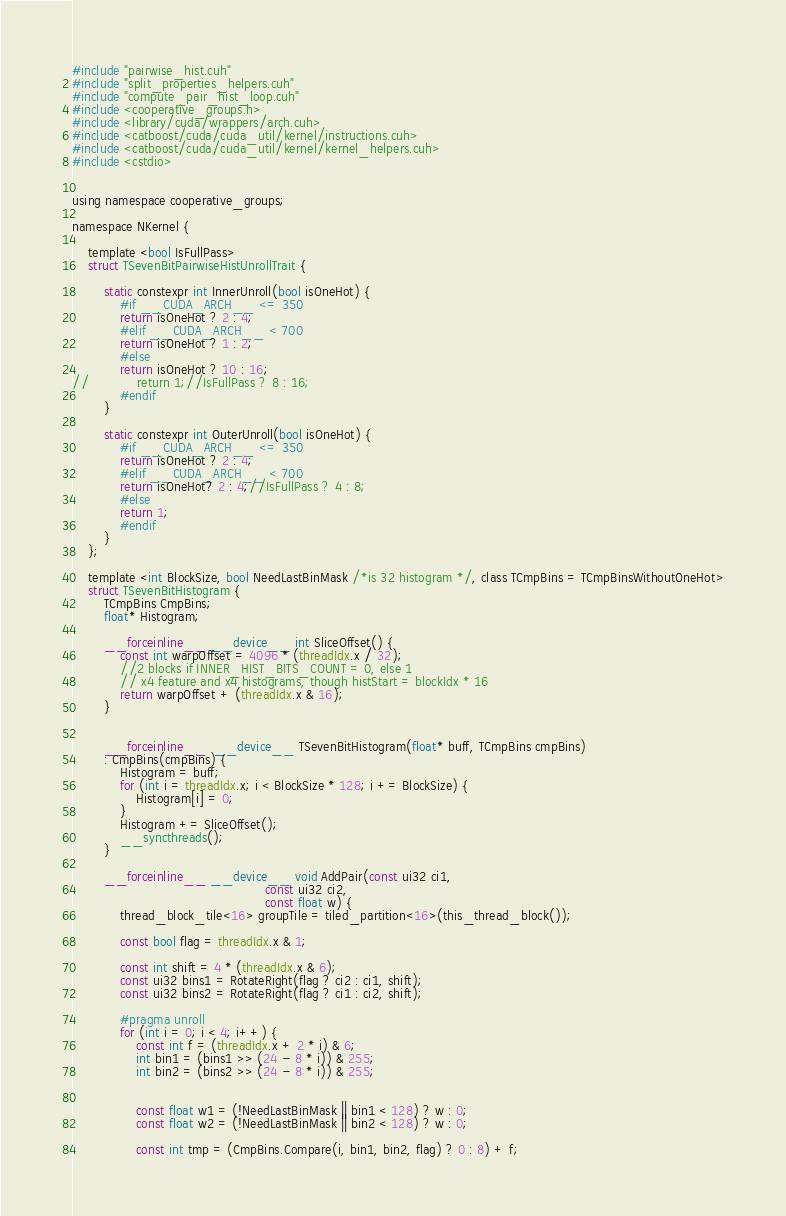Convert code to text. <code><loc_0><loc_0><loc_500><loc_500><_Cuda_>#include "pairwise_hist.cuh"
#include "split_properties_helpers.cuh"
#include "compute_pair_hist_loop.cuh"
#include <cooperative_groups.h>
#include <library/cuda/wrappers/arch.cuh>
#include <catboost/cuda/cuda_util/kernel/instructions.cuh>
#include <catboost/cuda/cuda_util/kernel/kernel_helpers.cuh>
#include <cstdio>


using namespace cooperative_groups;

namespace NKernel {

    template <bool IsFullPass>
    struct TSevenBitPairwiseHistUnrollTrait {

        static constexpr int InnerUnroll(bool isOneHot) {
            #if __CUDA_ARCH__ <= 350
            return isOneHot ? 2 : 4;
            #elif __CUDA_ARCH__ < 700
            return isOneHot ? 1 : 2;
            #else
            return isOneHot ? 10 : 16;
//            return 1;//IsFullPass ? 8 : 16;
            #endif
        }

        static constexpr int OuterUnroll(bool isOneHot) {
            #if __CUDA_ARCH__ <= 350
            return isOneHot ? 2 : 4;
            #elif __CUDA_ARCH__ < 700
            return isOneHot? 2 : 4;//IsFullPass ? 4 : 8;
            #else
            return 1;
            #endif
        }
    };

    template <int BlockSize, bool NeedLastBinMask /*is 32 histogram */, class TCmpBins = TCmpBinsWithoutOneHot>
    struct TSevenBitHistogram {
        TCmpBins CmpBins;
        float* Histogram;

        __forceinline__ __device__ int SliceOffset() {
            const int warpOffset = 4096 * (threadIdx.x / 32);
            //2 blocks if INNER_HIST_BITS_COUNT = 0, else 1
            // x4 feature and x4 histograms, though histStart = blockIdx * 16
            return warpOffset + (threadIdx.x & 16);
        }


        __forceinline__  __device__ TSevenBitHistogram(float* buff, TCmpBins cmpBins)
        : CmpBins(cmpBins) {
            Histogram = buff;
            for (int i = threadIdx.x; i < BlockSize * 128; i += BlockSize) {
                Histogram[i] = 0;
            }
            Histogram += SliceOffset();
            __syncthreads();
        }

        __forceinline__ __device__ void AddPair(const ui32 ci1,
                                                const ui32 ci2,
                                                const float w) {
            thread_block_tile<16> groupTile = tiled_partition<16>(this_thread_block());

            const bool flag = threadIdx.x & 1;

            const int shift = 4 * (threadIdx.x & 6);
            const ui32 bins1 = RotateRight(flag ? ci2 : ci1, shift);
            const ui32 bins2 = RotateRight(flag ? ci1 : ci2, shift);

            #pragma unroll
            for (int i = 0; i < 4; i++) {
                const int f = (threadIdx.x + 2 * i) & 6;
                int bin1 = (bins1 >> (24 - 8 * i)) & 255;
                int bin2 = (bins2 >> (24 - 8 * i)) & 255;


                const float w1 = (!NeedLastBinMask || bin1 < 128) ? w : 0;
                const float w2 = (!NeedLastBinMask || bin2 < 128) ? w : 0;

                const int tmp = (CmpBins.Compare(i, bin1, bin2, flag) ? 0 : 8) + f;
</code> 